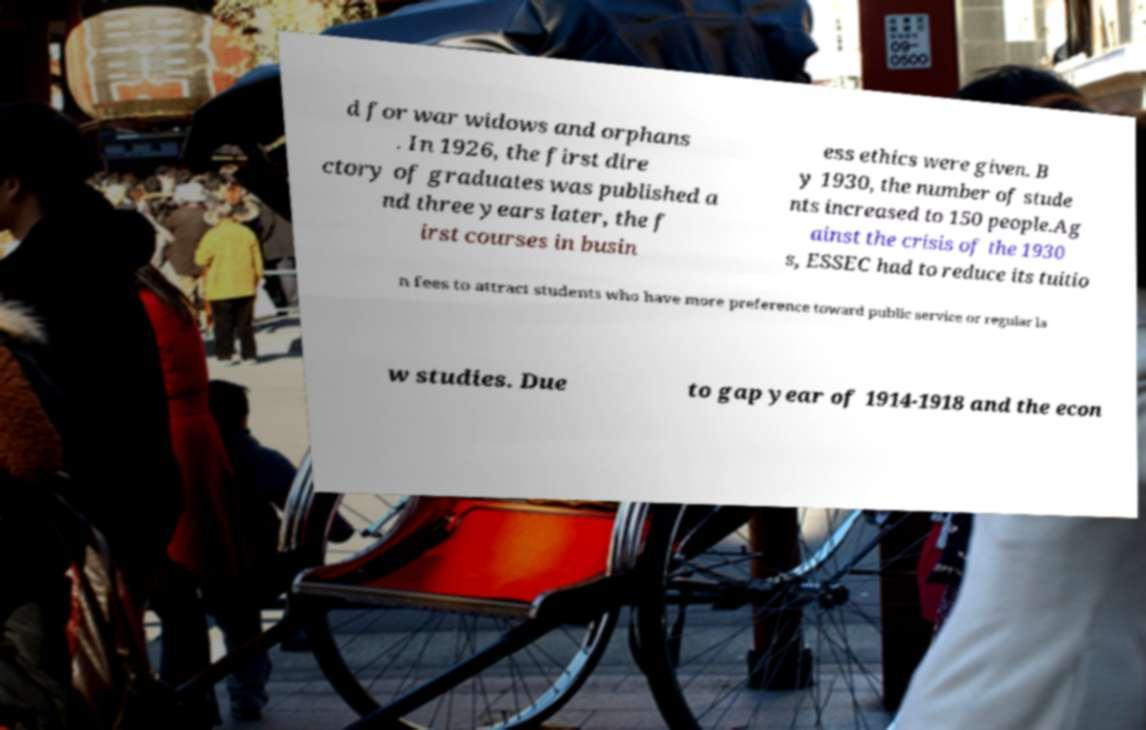What messages or text are displayed in this image? I need them in a readable, typed format. d for war widows and orphans . In 1926, the first dire ctory of graduates was published a nd three years later, the f irst courses in busin ess ethics were given. B y 1930, the number of stude nts increased to 150 people.Ag ainst the crisis of the 1930 s, ESSEC had to reduce its tuitio n fees to attract students who have more preference toward public service or regular la w studies. Due to gap year of 1914-1918 and the econ 